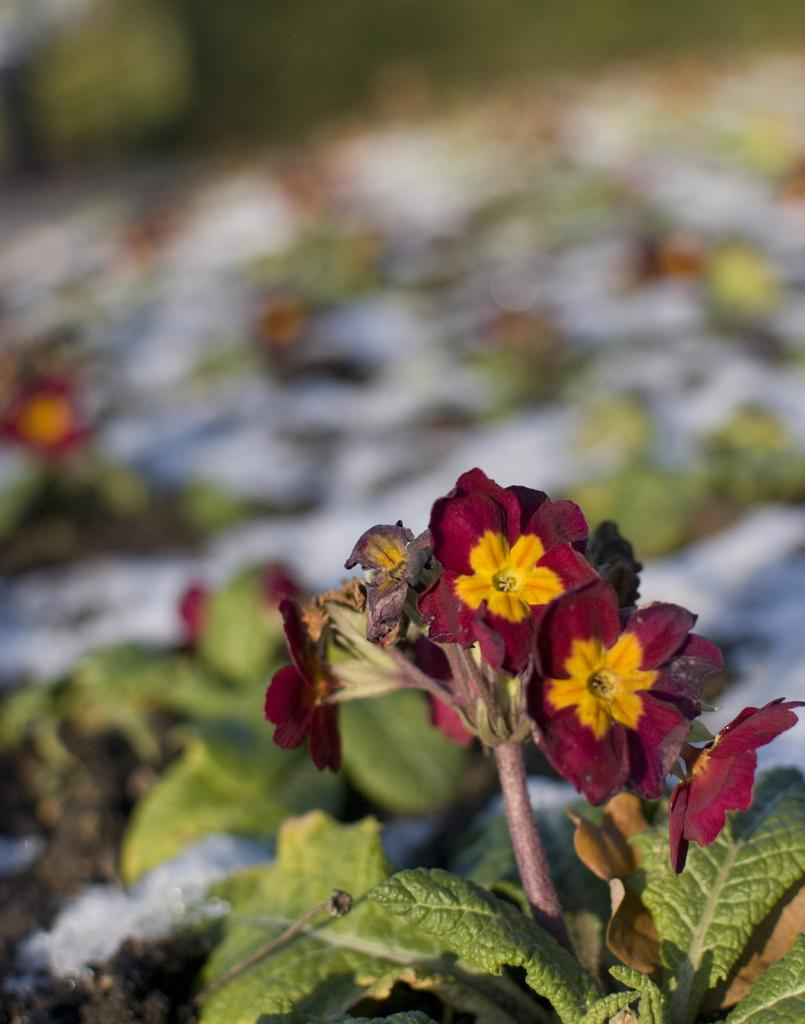What type of plant is visible in the image? There is a plant in the image. What features of the plant can be observed? The plant has flowers and leaves. What colors are the flowers? The flowers are maroon and yellow in color. How would you describe the background of the image? The background of the image appears blurry. Can you see a twig being used for a kiss in the image? There is no twig or any indication of a kiss present in the image. 